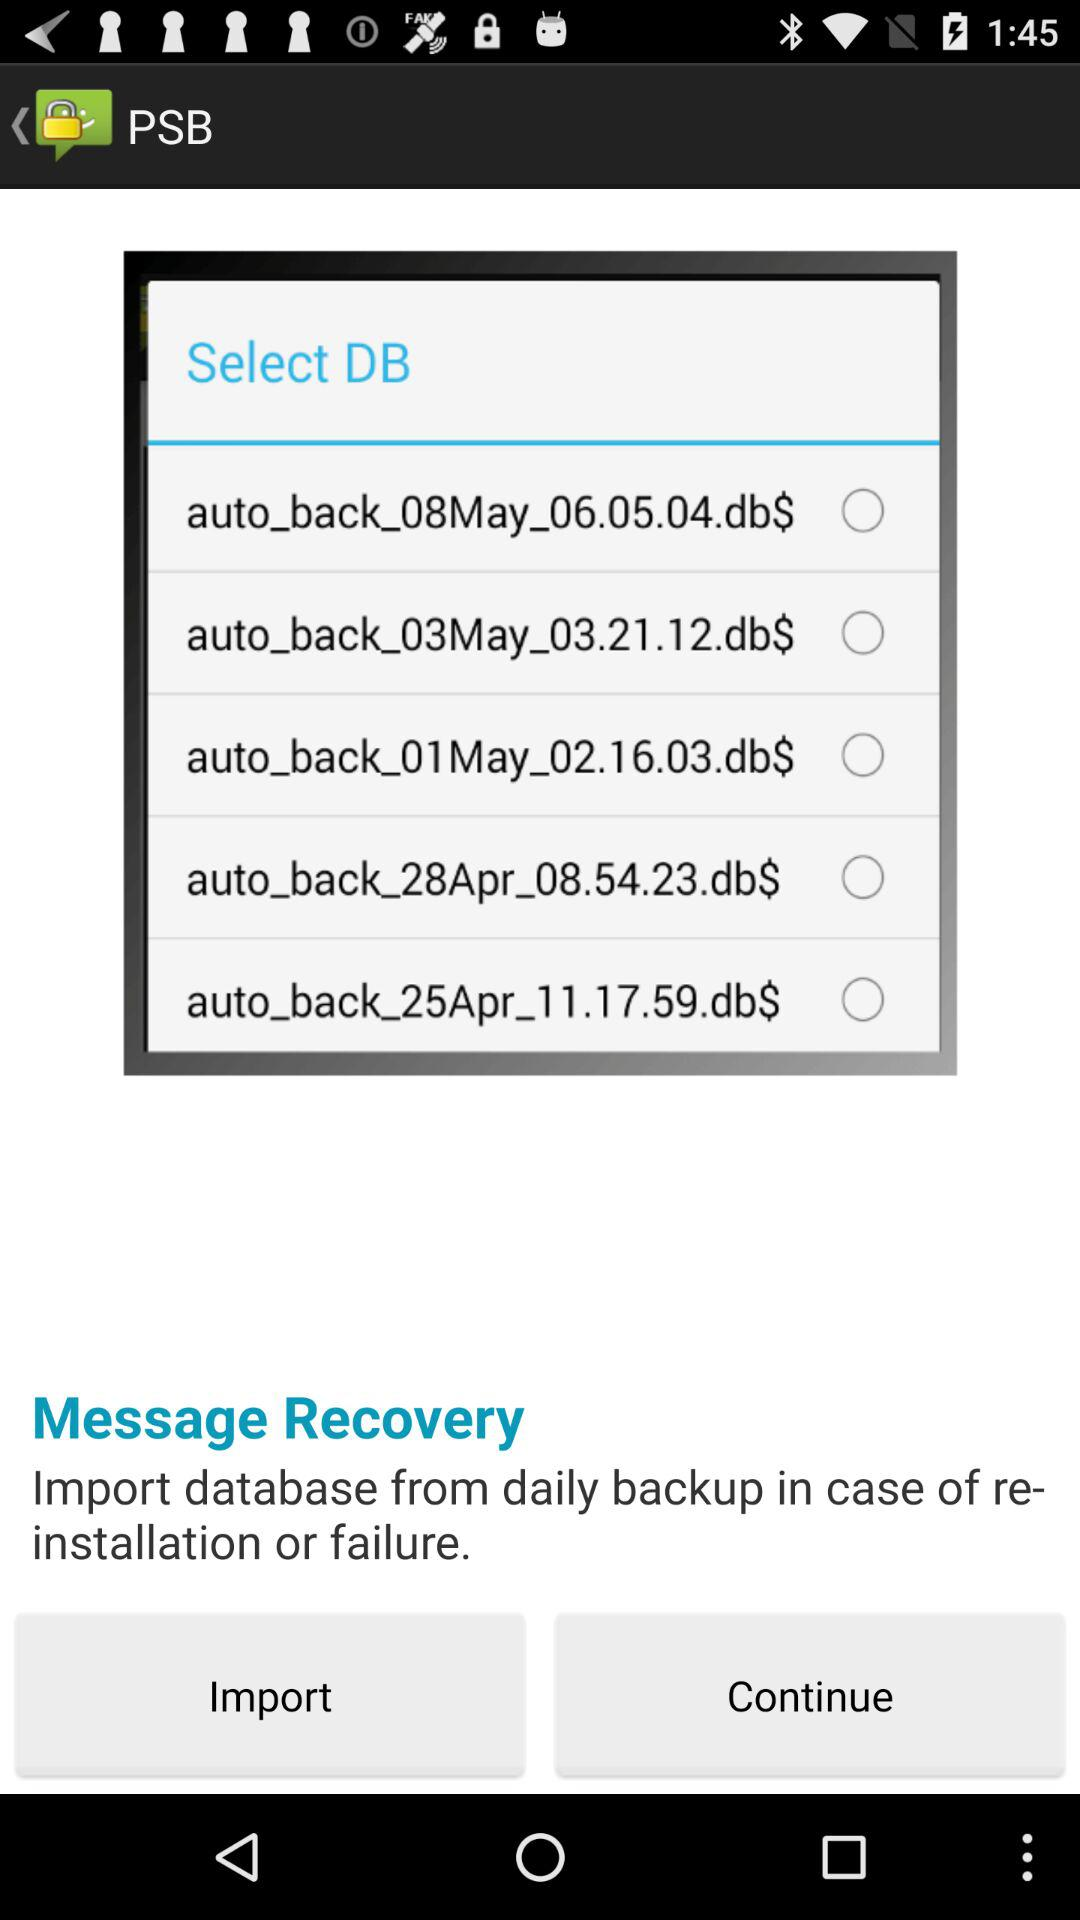What might be the significance of the different times listed in the filenames? The varying times in the filenames likely indicate the specific time each backup was created. This information allows users to pinpoint the most relevant backup version they might need to recover messages from a particular point in time. 